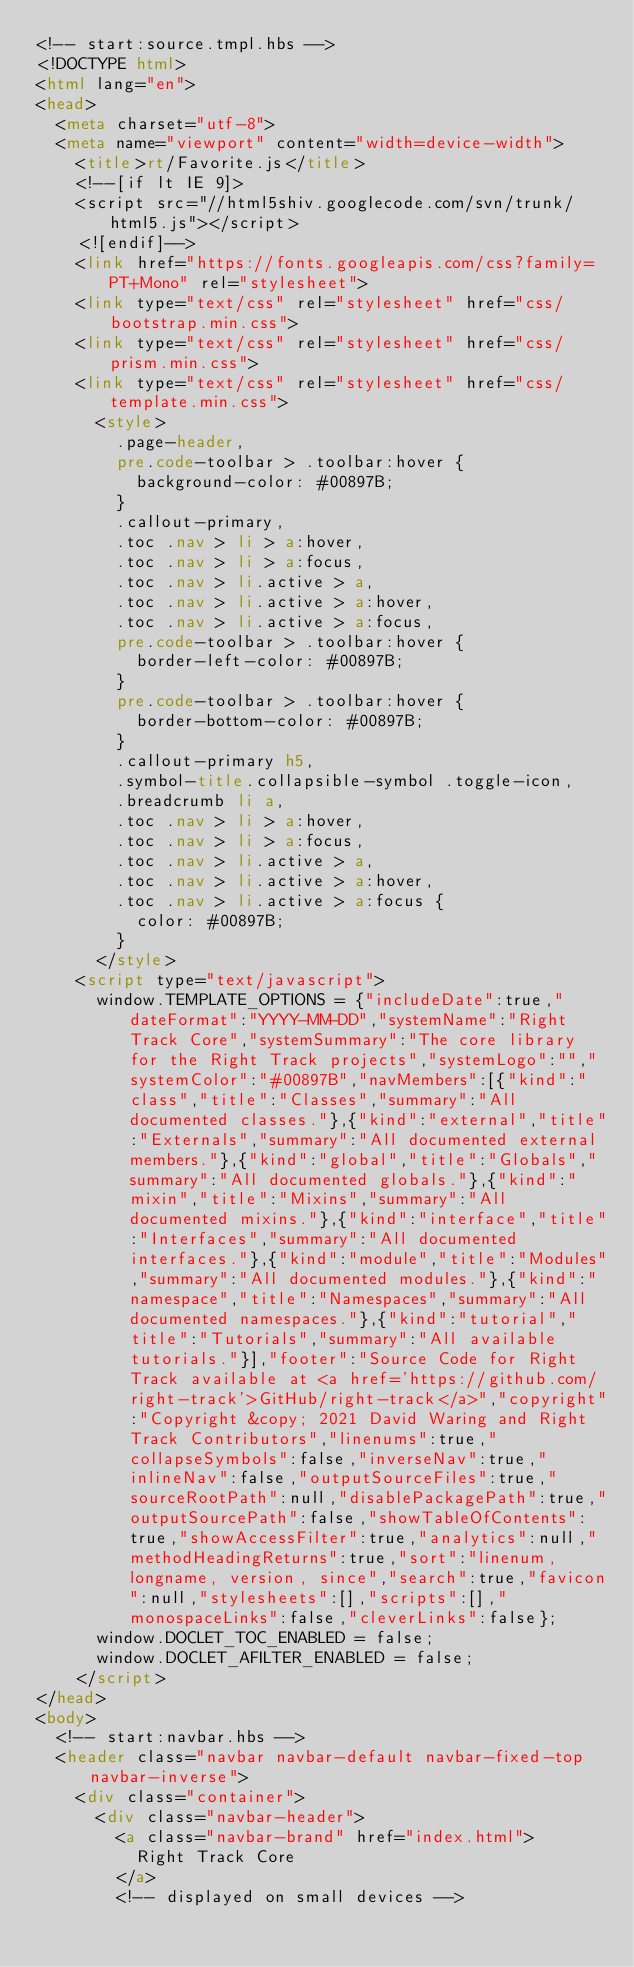Convert code to text. <code><loc_0><loc_0><loc_500><loc_500><_HTML_><!-- start:source.tmpl.hbs -->
<!DOCTYPE html>
<html lang="en">
<head>
	<meta charset="utf-8">
	<meta name="viewport" content="width=device-width">
		<title>rt/Favorite.js</title>
		<!--[if lt IE 9]>
		<script src="//html5shiv.googlecode.com/svn/trunk/html5.js"></script>
		<![endif]-->
		<link href="https://fonts.googleapis.com/css?family=PT+Mono" rel="stylesheet">
		<link type="text/css" rel="stylesheet" href="css/bootstrap.min.css">
		<link type="text/css" rel="stylesheet" href="css/prism.min.css">
		<link type="text/css" rel="stylesheet" href="css/template.min.css">
			<style>
				.page-header,
				pre.code-toolbar > .toolbar:hover {
					background-color: #00897B;
				}
				.callout-primary,
				.toc .nav > li > a:hover,
				.toc .nav > li > a:focus,
				.toc .nav > li.active > a,
				.toc .nav > li.active > a:hover,
				.toc .nav > li.active > a:focus,
				pre.code-toolbar > .toolbar:hover {
					border-left-color: #00897B;
				}
				pre.code-toolbar > .toolbar:hover {
					border-bottom-color: #00897B;
				}
				.callout-primary h5,
				.symbol-title.collapsible-symbol .toggle-icon,
				.breadcrumb li a,
				.toc .nav > li > a:hover,
				.toc .nav > li > a:focus,
				.toc .nav > li.active > a,
				.toc .nav > li.active > a:hover,
				.toc .nav > li.active > a:focus {
					color: #00897B;
				}
			</style>
		<script type="text/javascript">
			window.TEMPLATE_OPTIONS = {"includeDate":true,"dateFormat":"YYYY-MM-DD","systemName":"Right Track Core","systemSummary":"The core library for the Right Track projects","systemLogo":"","systemColor":"#00897B","navMembers":[{"kind":"class","title":"Classes","summary":"All documented classes."},{"kind":"external","title":"Externals","summary":"All documented external members."},{"kind":"global","title":"Globals","summary":"All documented globals."},{"kind":"mixin","title":"Mixins","summary":"All documented mixins."},{"kind":"interface","title":"Interfaces","summary":"All documented interfaces."},{"kind":"module","title":"Modules","summary":"All documented modules."},{"kind":"namespace","title":"Namespaces","summary":"All documented namespaces."},{"kind":"tutorial","title":"Tutorials","summary":"All available tutorials."}],"footer":"Source Code for Right Track available at <a href='https://github.com/right-track'>GitHub/right-track</a>","copyright":"Copyright &copy; 2021 David Waring and Right Track Contributors","linenums":true,"collapseSymbols":false,"inverseNav":true,"inlineNav":false,"outputSourceFiles":true,"sourceRootPath":null,"disablePackagePath":true,"outputSourcePath":false,"showTableOfContents":true,"showAccessFilter":true,"analytics":null,"methodHeadingReturns":true,"sort":"linenum, longname, version, since","search":true,"favicon":null,"stylesheets":[],"scripts":[],"monospaceLinks":false,"cleverLinks":false};
			window.DOCLET_TOC_ENABLED = false;
			window.DOCLET_AFILTER_ENABLED = false;
		</script>
</head>
<body>
	<!-- start:navbar.hbs -->
	<header class="navbar navbar-default navbar-fixed-top navbar-inverse">
		<div class="container">
			<div class="navbar-header">
				<a class="navbar-brand" href="index.html">
					Right Track Core
				</a>
				<!-- displayed on small devices --></code> 